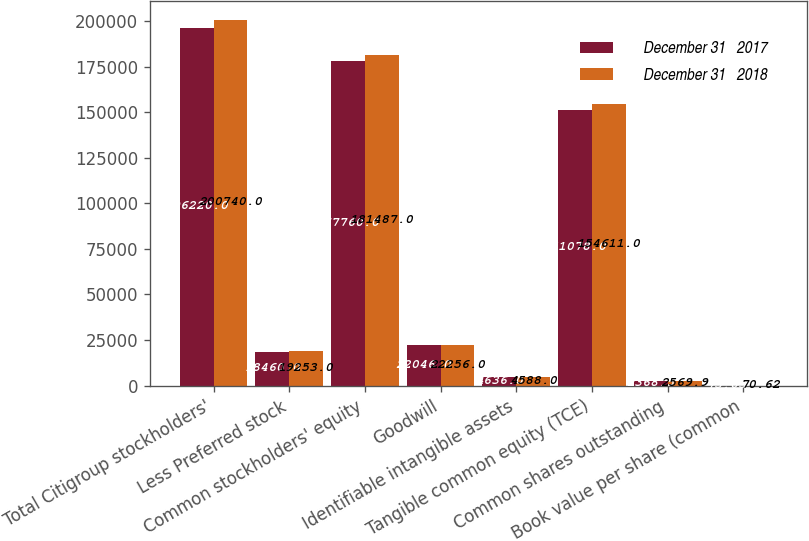Convert chart to OTSL. <chart><loc_0><loc_0><loc_500><loc_500><stacked_bar_chart><ecel><fcel>Total Citigroup stockholders'<fcel>Less Preferred stock<fcel>Common stockholders' equity<fcel>Goodwill<fcel>Identifiable intangible assets<fcel>Tangible common equity (TCE)<fcel>Common shares outstanding<fcel>Book value per share (common<nl><fcel>December 31   2017<fcel>196220<fcel>18460<fcel>177760<fcel>22046<fcel>4636<fcel>151078<fcel>2368.5<fcel>75.05<nl><fcel>December 31   2018<fcel>200740<fcel>19253<fcel>181487<fcel>22256<fcel>4588<fcel>154611<fcel>2569.9<fcel>70.62<nl></chart> 